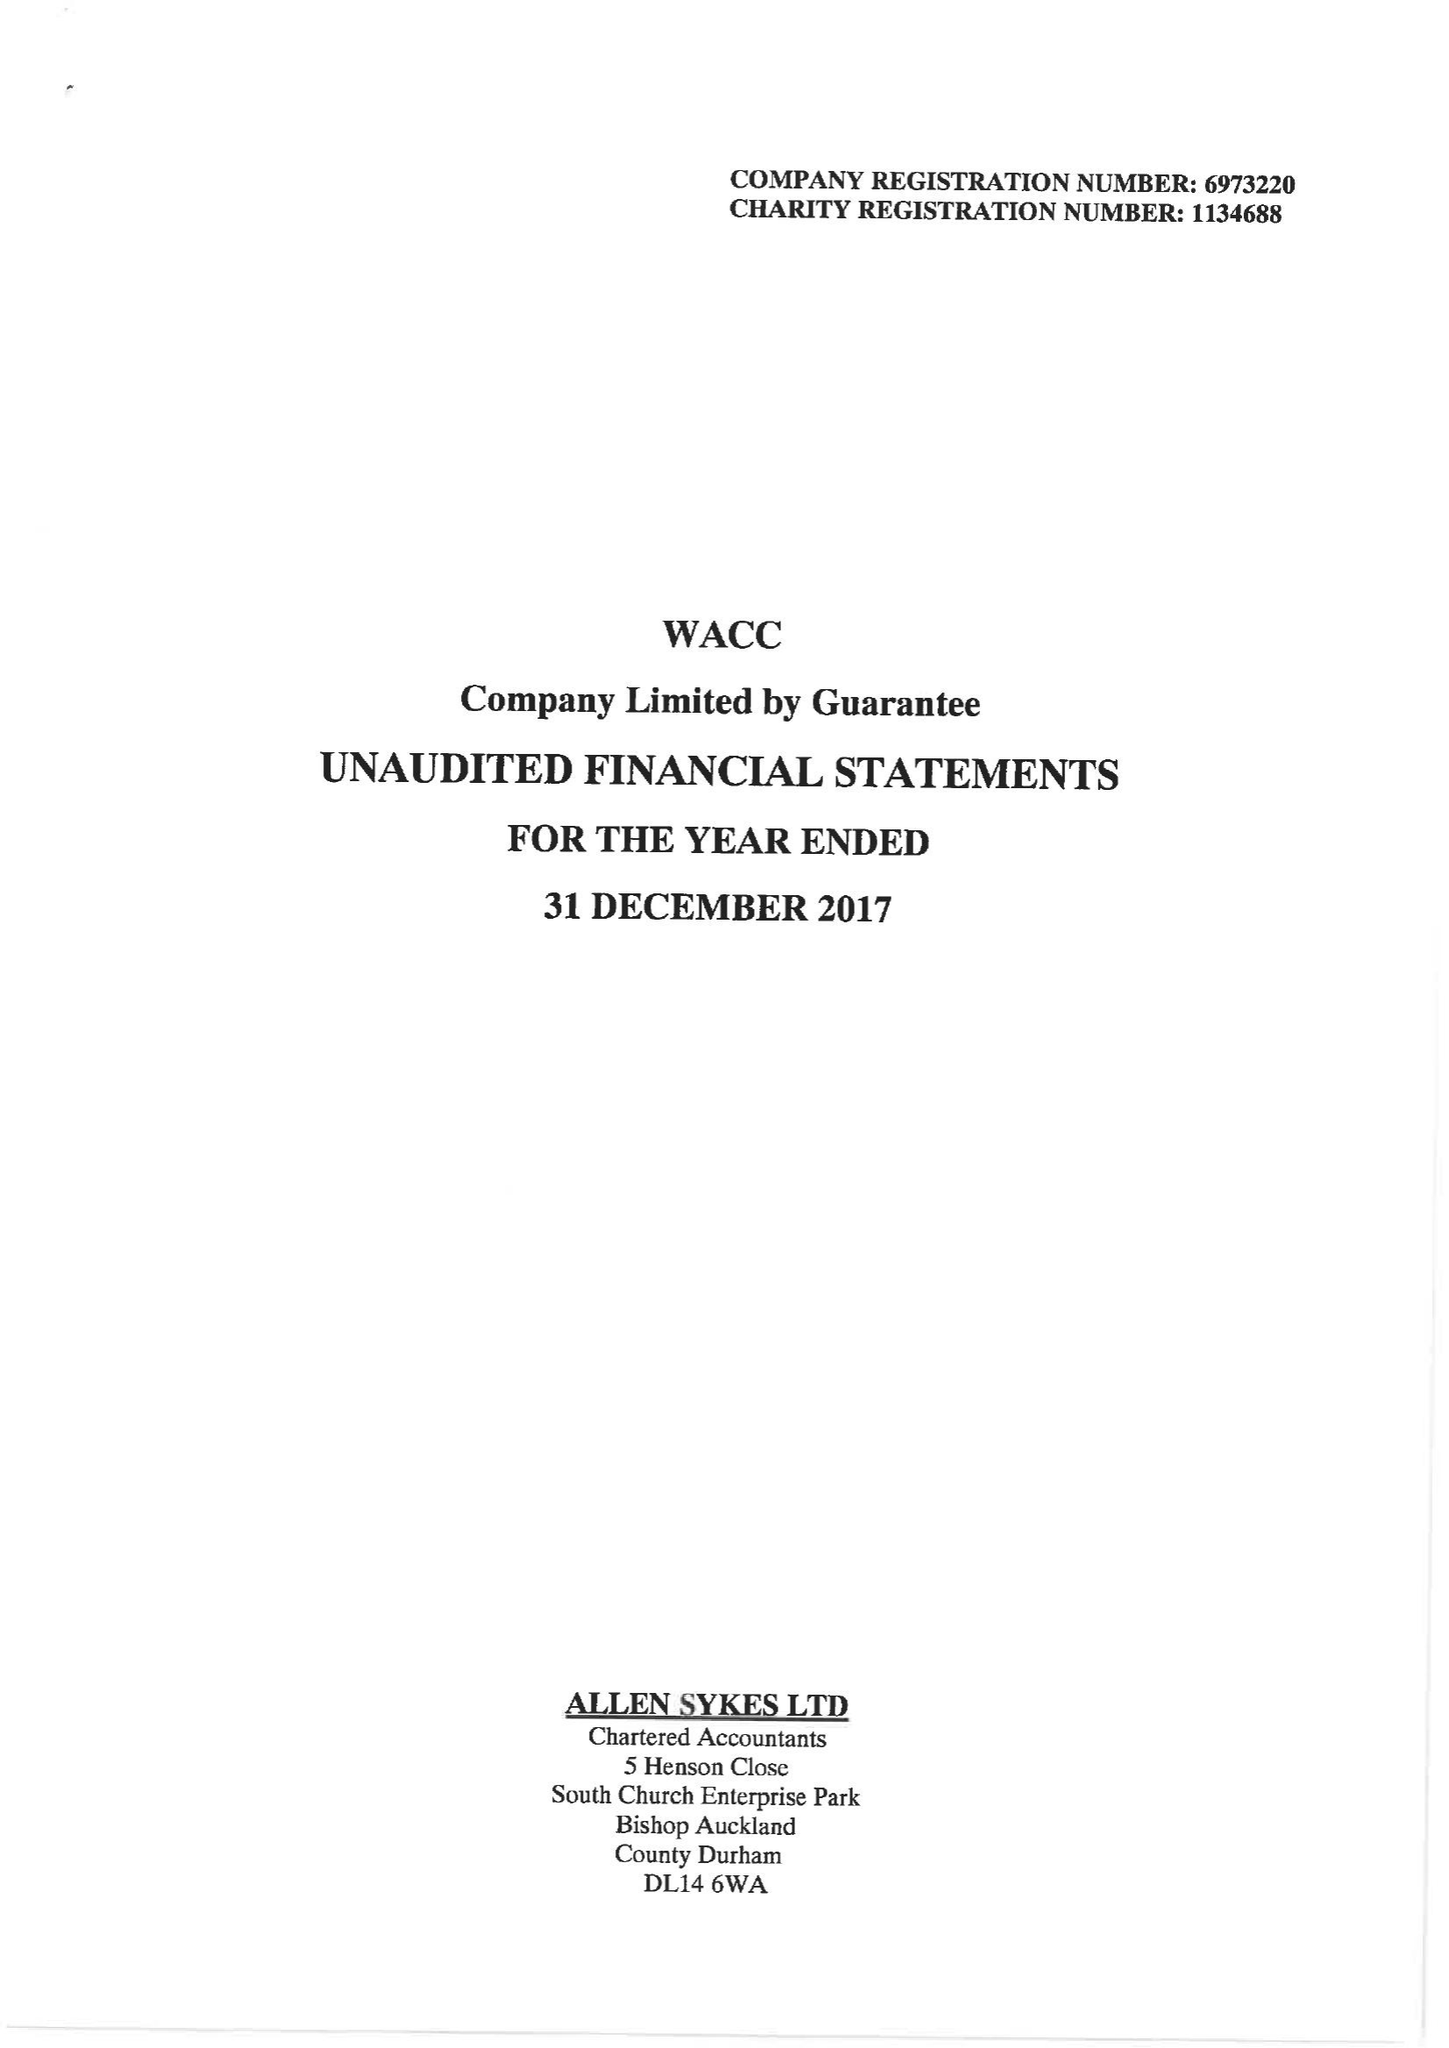What is the value for the address__post_town?
Answer the question using a single word or phrase. BISHOP AUCKLAND 